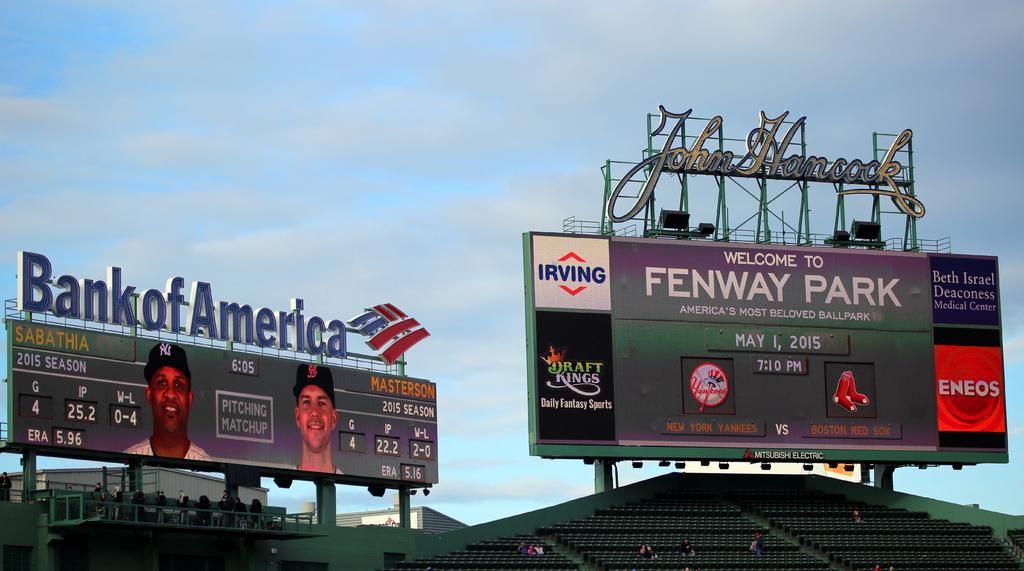What bank is on the scoreboard?
Keep it short and to the point. Bank of america. What park is this at?
Keep it short and to the point. Fenway. 